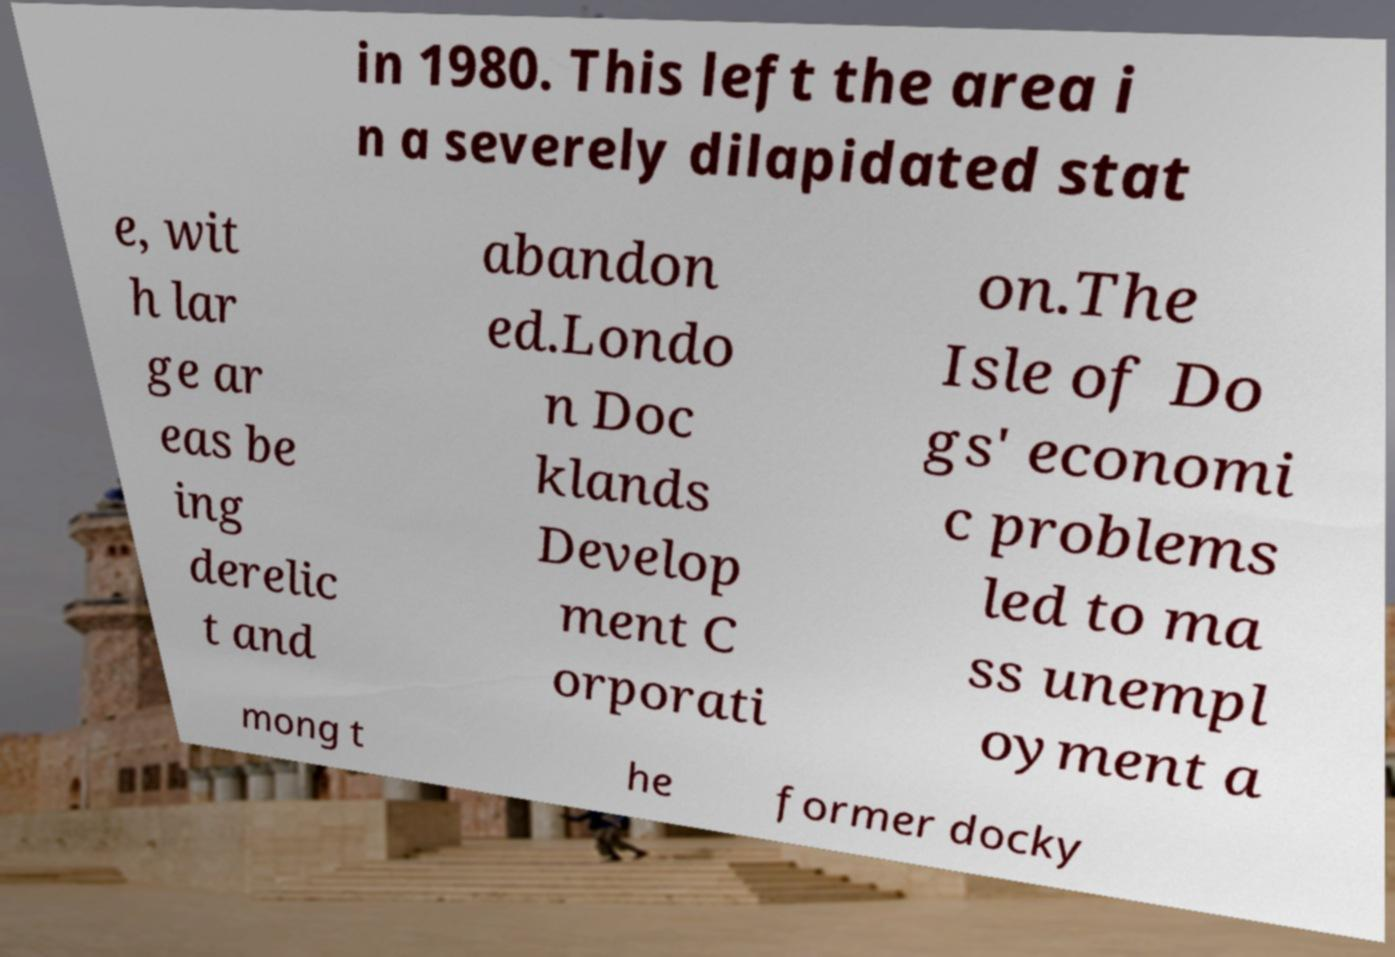Please identify and transcribe the text found in this image. in 1980. This left the area i n a severely dilapidated stat e, wit h lar ge ar eas be ing derelic t and abandon ed.Londo n Doc klands Develop ment C orporati on.The Isle of Do gs' economi c problems led to ma ss unempl oyment a mong t he former docky 